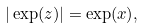<formula> <loc_0><loc_0><loc_500><loc_500>| \exp ( z ) | = \exp ( x ) ,</formula> 